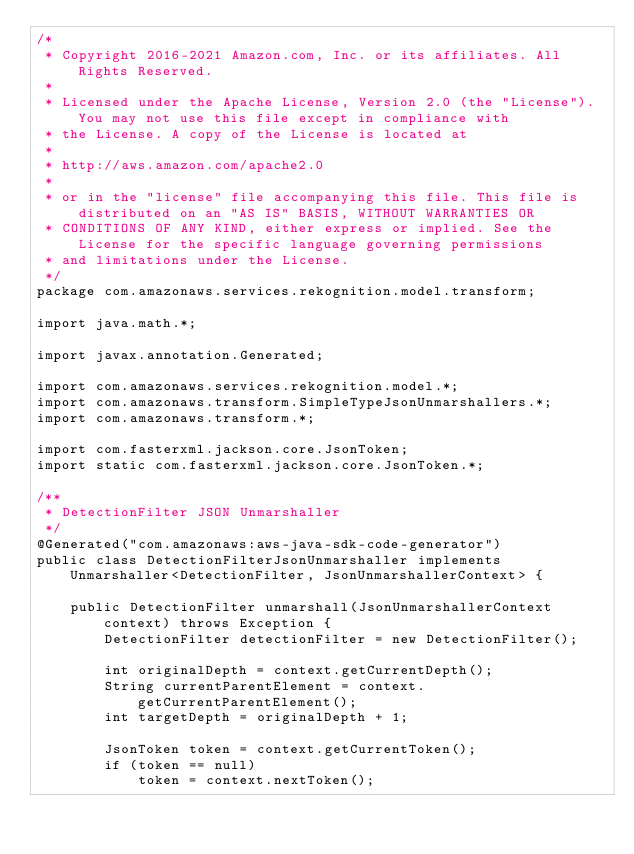<code> <loc_0><loc_0><loc_500><loc_500><_Java_>/*
 * Copyright 2016-2021 Amazon.com, Inc. or its affiliates. All Rights Reserved.
 * 
 * Licensed under the Apache License, Version 2.0 (the "License"). You may not use this file except in compliance with
 * the License. A copy of the License is located at
 * 
 * http://aws.amazon.com/apache2.0
 * 
 * or in the "license" file accompanying this file. This file is distributed on an "AS IS" BASIS, WITHOUT WARRANTIES OR
 * CONDITIONS OF ANY KIND, either express or implied. See the License for the specific language governing permissions
 * and limitations under the License.
 */
package com.amazonaws.services.rekognition.model.transform;

import java.math.*;

import javax.annotation.Generated;

import com.amazonaws.services.rekognition.model.*;
import com.amazonaws.transform.SimpleTypeJsonUnmarshallers.*;
import com.amazonaws.transform.*;

import com.fasterxml.jackson.core.JsonToken;
import static com.fasterxml.jackson.core.JsonToken.*;

/**
 * DetectionFilter JSON Unmarshaller
 */
@Generated("com.amazonaws:aws-java-sdk-code-generator")
public class DetectionFilterJsonUnmarshaller implements Unmarshaller<DetectionFilter, JsonUnmarshallerContext> {

    public DetectionFilter unmarshall(JsonUnmarshallerContext context) throws Exception {
        DetectionFilter detectionFilter = new DetectionFilter();

        int originalDepth = context.getCurrentDepth();
        String currentParentElement = context.getCurrentParentElement();
        int targetDepth = originalDepth + 1;

        JsonToken token = context.getCurrentToken();
        if (token == null)
            token = context.nextToken();</code> 